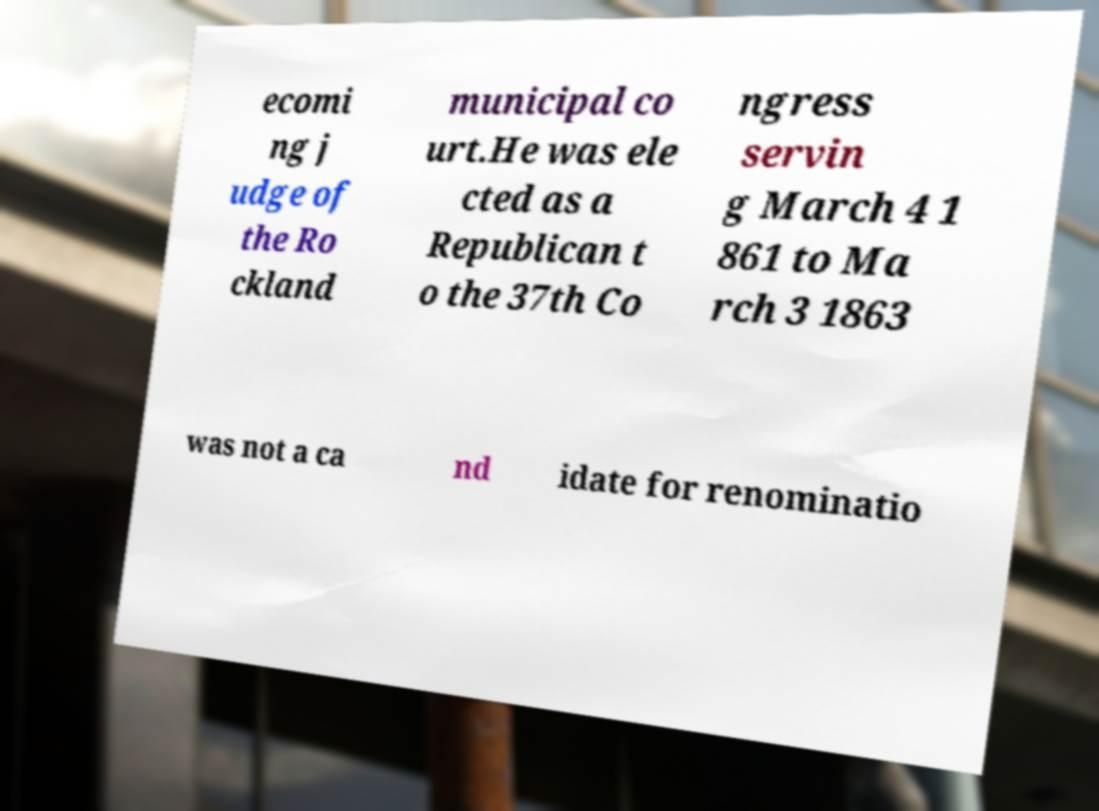I need the written content from this picture converted into text. Can you do that? ecomi ng j udge of the Ro ckland municipal co urt.He was ele cted as a Republican t o the 37th Co ngress servin g March 4 1 861 to Ma rch 3 1863 was not a ca nd idate for renominatio 